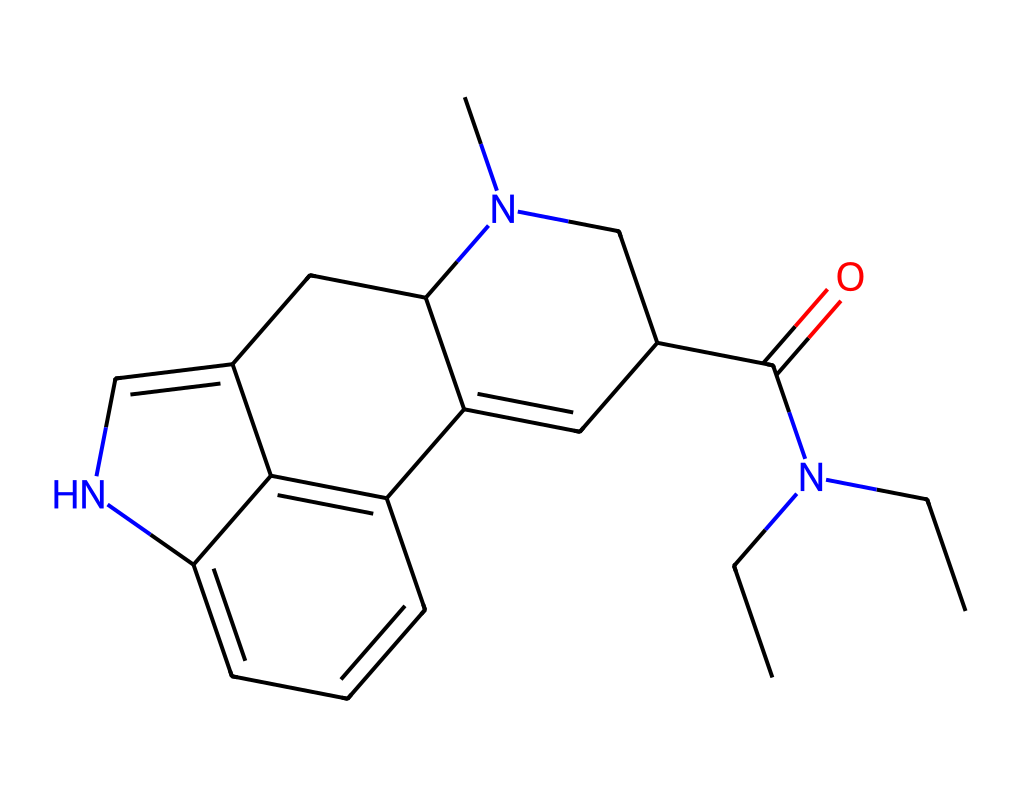What is the molecular formula of LSD? By analyzing the SMILES representation, we can count the number of carbon (C), hydrogen (H), nitrogen (N), and oxygen (O) atoms. The breakdown is: 20 carbons, 25 hydrogens, 3 nitrogens, and 1 oxygen. This leads to the molecular formula C20H25N3O.
Answer: C20H25N3O How many nitrogen atoms are present in the structure? In the SMILES representation, we can identify nitrogen atoms, represented by 'N'. By careful observation, we see three 'N' symbols in the structure, confirming there are three nitrogen atoms.
Answer: 3 What type of functional group is present in LSD? The presence of a nitrogen atom bonded to a carbonyl (C=O) indicates the presence of an amide functional group in the structure. This function characterizes LSD as a compound with the amide group.
Answer: amide Which part of the structure is responsible for LSD's psychoactive effects? The bicyclic structure involving the indole-like component is pivotal for psychoactivity. The combination of fused rings and nitrogen atoms in this part of the molecule is crucial for its interaction with serotonin receptors.
Answer: bicyclic structure Is LSD a basic or acidic compound? The nitrogen atoms in the structure suggest the potential for protonation, which imparts basic characteristics to LSD, allowing it to interact with various biological systems.
Answer: basic 